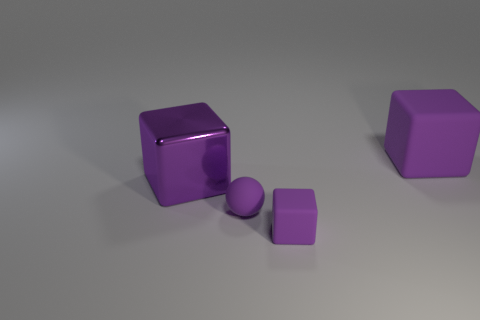How many small cyan cylinders are the same material as the sphere?
Make the answer very short. 0. How many small matte cubes are to the left of the big rubber object?
Offer a very short reply. 1. Does the object to the left of the ball have the same material as the large purple cube that is to the right of the purple sphere?
Keep it short and to the point. No. Is the number of big shiny blocks that are in front of the tiny purple rubber block greater than the number of small objects in front of the small purple rubber ball?
Offer a very short reply. No. There is another large thing that is the same color as the big rubber thing; what material is it?
Offer a very short reply. Metal. Are there any other things that are the same shape as the large matte thing?
Your response must be concise. Yes. What is the material of the purple object that is in front of the large shiny thing and on the right side of the small purple ball?
Your response must be concise. Rubber. Is the sphere made of the same material as the purple block on the left side of the purple sphere?
Your response must be concise. No. Is there anything else that is the same size as the purple shiny block?
Your response must be concise. Yes. How many objects are tiny cubes or purple blocks in front of the metal cube?
Keep it short and to the point. 1. 